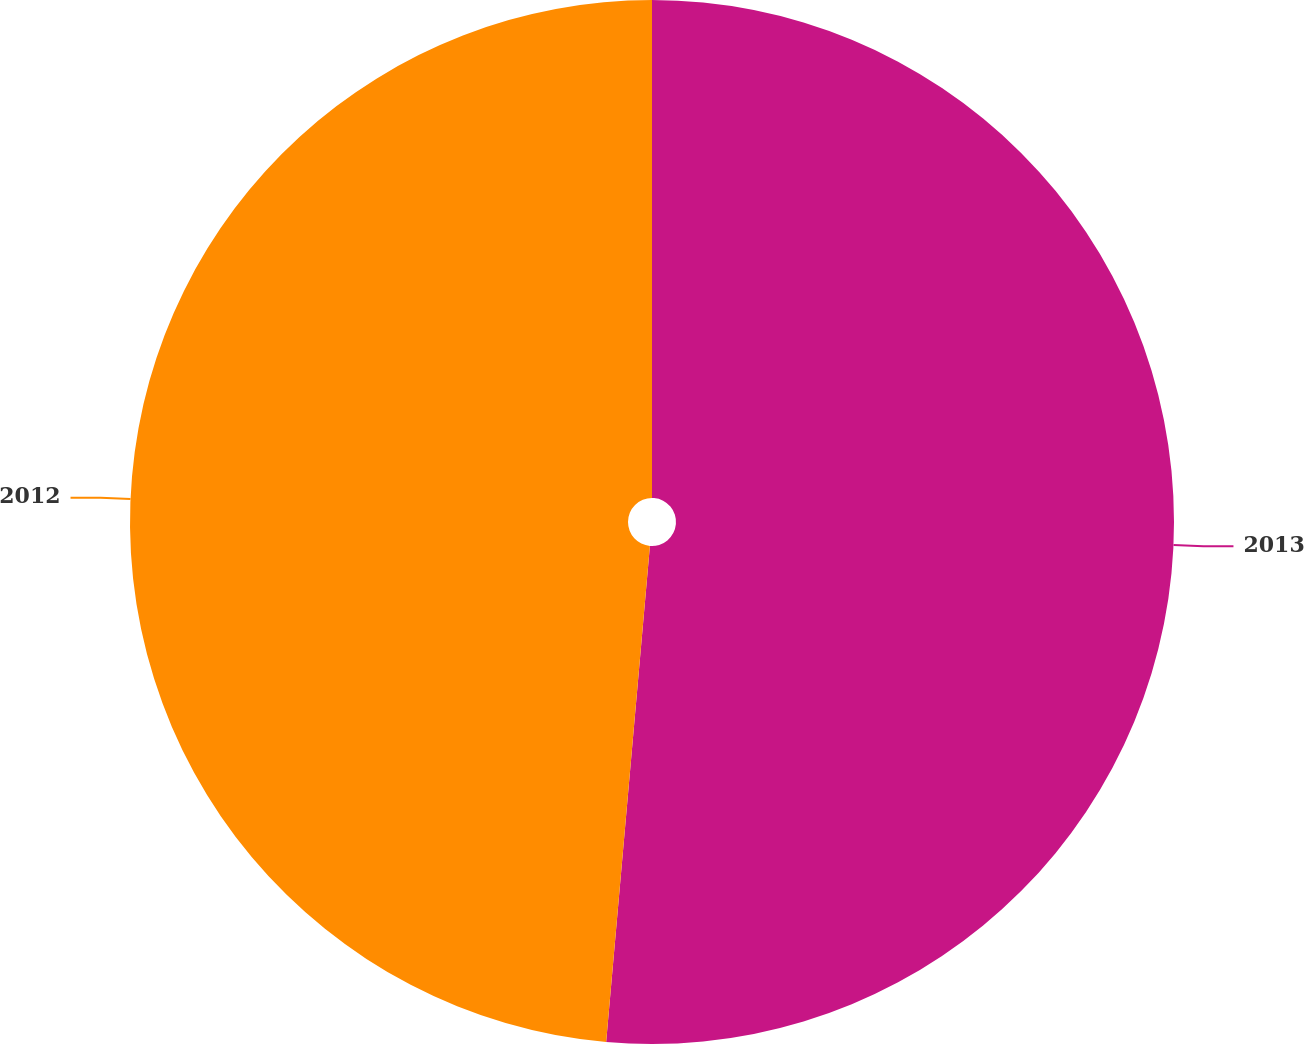Convert chart to OTSL. <chart><loc_0><loc_0><loc_500><loc_500><pie_chart><fcel>2013<fcel>2012<nl><fcel>51.4%<fcel>48.6%<nl></chart> 